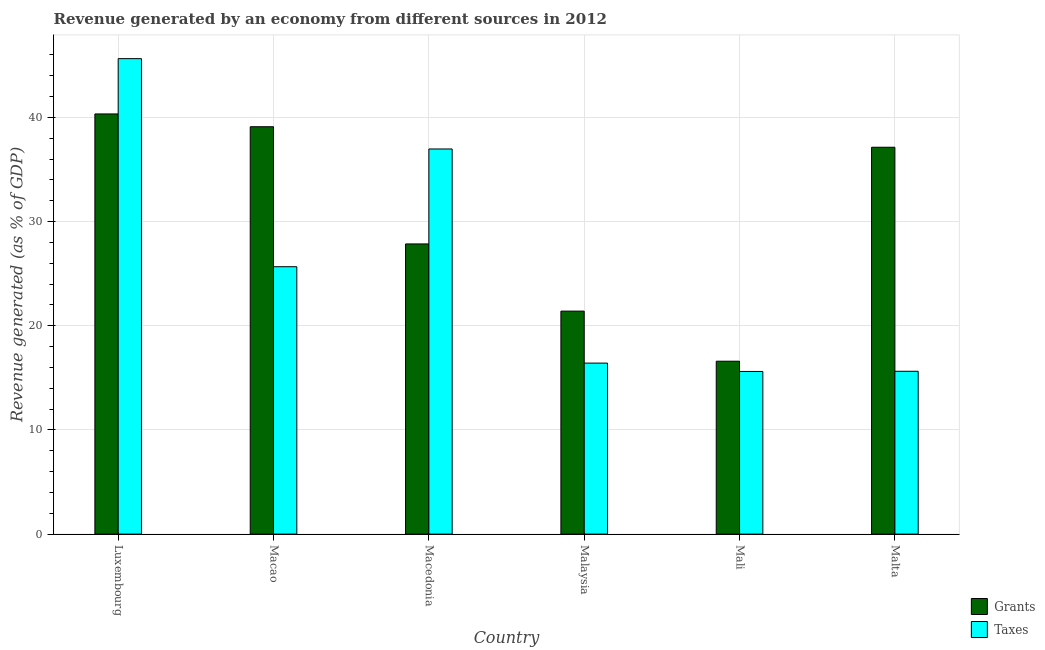How many different coloured bars are there?
Keep it short and to the point. 2. How many groups of bars are there?
Make the answer very short. 6. How many bars are there on the 2nd tick from the left?
Your response must be concise. 2. How many bars are there on the 5th tick from the right?
Your answer should be compact. 2. What is the label of the 3rd group of bars from the left?
Give a very brief answer. Macedonia. What is the revenue generated by grants in Macedonia?
Keep it short and to the point. 27.86. Across all countries, what is the maximum revenue generated by grants?
Your response must be concise. 40.34. Across all countries, what is the minimum revenue generated by grants?
Your answer should be very brief. 16.6. In which country was the revenue generated by taxes maximum?
Give a very brief answer. Luxembourg. In which country was the revenue generated by taxes minimum?
Ensure brevity in your answer.  Mali. What is the total revenue generated by grants in the graph?
Offer a very short reply. 182.44. What is the difference between the revenue generated by grants in Macao and that in Malaysia?
Your answer should be compact. 17.7. What is the difference between the revenue generated by taxes in Macao and the revenue generated by grants in Malta?
Provide a succinct answer. -11.47. What is the average revenue generated by taxes per country?
Your answer should be very brief. 25.99. What is the difference between the revenue generated by taxes and revenue generated by grants in Malaysia?
Give a very brief answer. -4.99. What is the ratio of the revenue generated by taxes in Malaysia to that in Malta?
Your answer should be very brief. 1.05. What is the difference between the highest and the second highest revenue generated by grants?
Provide a short and direct response. 1.23. What is the difference between the highest and the lowest revenue generated by taxes?
Make the answer very short. 30.03. In how many countries, is the revenue generated by taxes greater than the average revenue generated by taxes taken over all countries?
Give a very brief answer. 2. Is the sum of the revenue generated by taxes in Malaysia and Mali greater than the maximum revenue generated by grants across all countries?
Make the answer very short. No. What does the 2nd bar from the left in Luxembourg represents?
Your answer should be very brief. Taxes. What does the 1st bar from the right in Macedonia represents?
Offer a terse response. Taxes. Are all the bars in the graph horizontal?
Your answer should be compact. No. What is the difference between two consecutive major ticks on the Y-axis?
Offer a very short reply. 10. Are the values on the major ticks of Y-axis written in scientific E-notation?
Offer a terse response. No. Does the graph contain grids?
Provide a succinct answer. Yes. How many legend labels are there?
Give a very brief answer. 2. What is the title of the graph?
Your answer should be compact. Revenue generated by an economy from different sources in 2012. Does "Frequency of shipment arrival" appear as one of the legend labels in the graph?
Offer a terse response. No. What is the label or title of the Y-axis?
Provide a succinct answer. Revenue generated (as % of GDP). What is the Revenue generated (as % of GDP) in Grants in Luxembourg?
Offer a very short reply. 40.34. What is the Revenue generated (as % of GDP) in Taxes in Luxembourg?
Make the answer very short. 45.64. What is the Revenue generated (as % of GDP) in Grants in Macao?
Ensure brevity in your answer.  39.11. What is the Revenue generated (as % of GDP) in Taxes in Macao?
Keep it short and to the point. 25.67. What is the Revenue generated (as % of GDP) of Grants in Macedonia?
Provide a short and direct response. 27.86. What is the Revenue generated (as % of GDP) in Taxes in Macedonia?
Provide a short and direct response. 36.97. What is the Revenue generated (as % of GDP) in Grants in Malaysia?
Make the answer very short. 21.41. What is the Revenue generated (as % of GDP) in Taxes in Malaysia?
Keep it short and to the point. 16.42. What is the Revenue generated (as % of GDP) of Grants in Mali?
Your answer should be compact. 16.6. What is the Revenue generated (as % of GDP) of Taxes in Mali?
Provide a short and direct response. 15.61. What is the Revenue generated (as % of GDP) of Grants in Malta?
Ensure brevity in your answer.  37.14. What is the Revenue generated (as % of GDP) in Taxes in Malta?
Your response must be concise. 15.63. Across all countries, what is the maximum Revenue generated (as % of GDP) in Grants?
Give a very brief answer. 40.34. Across all countries, what is the maximum Revenue generated (as % of GDP) in Taxes?
Your answer should be compact. 45.64. Across all countries, what is the minimum Revenue generated (as % of GDP) in Grants?
Give a very brief answer. 16.6. Across all countries, what is the minimum Revenue generated (as % of GDP) of Taxes?
Offer a very short reply. 15.61. What is the total Revenue generated (as % of GDP) in Grants in the graph?
Provide a succinct answer. 182.44. What is the total Revenue generated (as % of GDP) in Taxes in the graph?
Offer a very short reply. 155.95. What is the difference between the Revenue generated (as % of GDP) in Grants in Luxembourg and that in Macao?
Keep it short and to the point. 1.23. What is the difference between the Revenue generated (as % of GDP) in Taxes in Luxembourg and that in Macao?
Your answer should be very brief. 19.97. What is the difference between the Revenue generated (as % of GDP) of Grants in Luxembourg and that in Macedonia?
Give a very brief answer. 12.48. What is the difference between the Revenue generated (as % of GDP) of Taxes in Luxembourg and that in Macedonia?
Make the answer very short. 8.67. What is the difference between the Revenue generated (as % of GDP) of Grants in Luxembourg and that in Malaysia?
Your answer should be very brief. 18.93. What is the difference between the Revenue generated (as % of GDP) of Taxes in Luxembourg and that in Malaysia?
Provide a succinct answer. 29.23. What is the difference between the Revenue generated (as % of GDP) of Grants in Luxembourg and that in Mali?
Your answer should be compact. 23.74. What is the difference between the Revenue generated (as % of GDP) in Taxes in Luxembourg and that in Mali?
Provide a succinct answer. 30.03. What is the difference between the Revenue generated (as % of GDP) of Grants in Luxembourg and that in Malta?
Your response must be concise. 3.2. What is the difference between the Revenue generated (as % of GDP) of Taxes in Luxembourg and that in Malta?
Your answer should be very brief. 30.01. What is the difference between the Revenue generated (as % of GDP) of Grants in Macao and that in Macedonia?
Make the answer very short. 11.25. What is the difference between the Revenue generated (as % of GDP) of Taxes in Macao and that in Macedonia?
Make the answer very short. -11.3. What is the difference between the Revenue generated (as % of GDP) in Grants in Macao and that in Malaysia?
Your response must be concise. 17.7. What is the difference between the Revenue generated (as % of GDP) in Taxes in Macao and that in Malaysia?
Your answer should be very brief. 9.25. What is the difference between the Revenue generated (as % of GDP) of Grants in Macao and that in Mali?
Provide a short and direct response. 22.51. What is the difference between the Revenue generated (as % of GDP) in Taxes in Macao and that in Mali?
Ensure brevity in your answer.  10.06. What is the difference between the Revenue generated (as % of GDP) of Grants in Macao and that in Malta?
Offer a very short reply. 1.97. What is the difference between the Revenue generated (as % of GDP) in Taxes in Macao and that in Malta?
Provide a short and direct response. 10.04. What is the difference between the Revenue generated (as % of GDP) of Grants in Macedonia and that in Malaysia?
Your answer should be compact. 6.45. What is the difference between the Revenue generated (as % of GDP) in Taxes in Macedonia and that in Malaysia?
Give a very brief answer. 20.56. What is the difference between the Revenue generated (as % of GDP) of Grants in Macedonia and that in Mali?
Make the answer very short. 11.26. What is the difference between the Revenue generated (as % of GDP) of Taxes in Macedonia and that in Mali?
Offer a very short reply. 21.36. What is the difference between the Revenue generated (as % of GDP) of Grants in Macedonia and that in Malta?
Offer a terse response. -9.28. What is the difference between the Revenue generated (as % of GDP) in Taxes in Macedonia and that in Malta?
Your response must be concise. 21.34. What is the difference between the Revenue generated (as % of GDP) of Grants in Malaysia and that in Mali?
Give a very brief answer. 4.81. What is the difference between the Revenue generated (as % of GDP) in Taxes in Malaysia and that in Mali?
Ensure brevity in your answer.  0.8. What is the difference between the Revenue generated (as % of GDP) of Grants in Malaysia and that in Malta?
Provide a succinct answer. -15.73. What is the difference between the Revenue generated (as % of GDP) of Taxes in Malaysia and that in Malta?
Keep it short and to the point. 0.78. What is the difference between the Revenue generated (as % of GDP) in Grants in Mali and that in Malta?
Make the answer very short. -20.54. What is the difference between the Revenue generated (as % of GDP) of Taxes in Mali and that in Malta?
Your answer should be very brief. -0.02. What is the difference between the Revenue generated (as % of GDP) in Grants in Luxembourg and the Revenue generated (as % of GDP) in Taxes in Macao?
Make the answer very short. 14.67. What is the difference between the Revenue generated (as % of GDP) in Grants in Luxembourg and the Revenue generated (as % of GDP) in Taxes in Macedonia?
Keep it short and to the point. 3.36. What is the difference between the Revenue generated (as % of GDP) in Grants in Luxembourg and the Revenue generated (as % of GDP) in Taxes in Malaysia?
Ensure brevity in your answer.  23.92. What is the difference between the Revenue generated (as % of GDP) in Grants in Luxembourg and the Revenue generated (as % of GDP) in Taxes in Mali?
Your answer should be compact. 24.72. What is the difference between the Revenue generated (as % of GDP) in Grants in Luxembourg and the Revenue generated (as % of GDP) in Taxes in Malta?
Give a very brief answer. 24.7. What is the difference between the Revenue generated (as % of GDP) in Grants in Macao and the Revenue generated (as % of GDP) in Taxes in Macedonia?
Offer a terse response. 2.14. What is the difference between the Revenue generated (as % of GDP) in Grants in Macao and the Revenue generated (as % of GDP) in Taxes in Malaysia?
Your answer should be very brief. 22.69. What is the difference between the Revenue generated (as % of GDP) in Grants in Macao and the Revenue generated (as % of GDP) in Taxes in Mali?
Your response must be concise. 23.49. What is the difference between the Revenue generated (as % of GDP) in Grants in Macao and the Revenue generated (as % of GDP) in Taxes in Malta?
Offer a terse response. 23.48. What is the difference between the Revenue generated (as % of GDP) in Grants in Macedonia and the Revenue generated (as % of GDP) in Taxes in Malaysia?
Your answer should be very brief. 11.44. What is the difference between the Revenue generated (as % of GDP) in Grants in Macedonia and the Revenue generated (as % of GDP) in Taxes in Mali?
Provide a short and direct response. 12.24. What is the difference between the Revenue generated (as % of GDP) of Grants in Macedonia and the Revenue generated (as % of GDP) of Taxes in Malta?
Offer a terse response. 12.22. What is the difference between the Revenue generated (as % of GDP) of Grants in Malaysia and the Revenue generated (as % of GDP) of Taxes in Mali?
Provide a succinct answer. 5.79. What is the difference between the Revenue generated (as % of GDP) in Grants in Malaysia and the Revenue generated (as % of GDP) in Taxes in Malta?
Provide a short and direct response. 5.77. What is the average Revenue generated (as % of GDP) in Grants per country?
Provide a short and direct response. 30.41. What is the average Revenue generated (as % of GDP) of Taxes per country?
Provide a succinct answer. 25.99. What is the difference between the Revenue generated (as % of GDP) of Grants and Revenue generated (as % of GDP) of Taxes in Luxembourg?
Offer a terse response. -5.31. What is the difference between the Revenue generated (as % of GDP) of Grants and Revenue generated (as % of GDP) of Taxes in Macao?
Offer a terse response. 13.44. What is the difference between the Revenue generated (as % of GDP) of Grants and Revenue generated (as % of GDP) of Taxes in Macedonia?
Your answer should be compact. -9.12. What is the difference between the Revenue generated (as % of GDP) in Grants and Revenue generated (as % of GDP) in Taxes in Malaysia?
Make the answer very short. 4.99. What is the difference between the Revenue generated (as % of GDP) in Grants and Revenue generated (as % of GDP) in Taxes in Mali?
Give a very brief answer. 0.98. What is the difference between the Revenue generated (as % of GDP) in Grants and Revenue generated (as % of GDP) in Taxes in Malta?
Offer a very short reply. 21.51. What is the ratio of the Revenue generated (as % of GDP) in Grants in Luxembourg to that in Macao?
Provide a short and direct response. 1.03. What is the ratio of the Revenue generated (as % of GDP) of Taxes in Luxembourg to that in Macao?
Your response must be concise. 1.78. What is the ratio of the Revenue generated (as % of GDP) of Grants in Luxembourg to that in Macedonia?
Your response must be concise. 1.45. What is the ratio of the Revenue generated (as % of GDP) in Taxes in Luxembourg to that in Macedonia?
Your answer should be very brief. 1.23. What is the ratio of the Revenue generated (as % of GDP) in Grants in Luxembourg to that in Malaysia?
Your answer should be compact. 1.88. What is the ratio of the Revenue generated (as % of GDP) of Taxes in Luxembourg to that in Malaysia?
Provide a short and direct response. 2.78. What is the ratio of the Revenue generated (as % of GDP) of Grants in Luxembourg to that in Mali?
Offer a terse response. 2.43. What is the ratio of the Revenue generated (as % of GDP) in Taxes in Luxembourg to that in Mali?
Your answer should be very brief. 2.92. What is the ratio of the Revenue generated (as % of GDP) in Grants in Luxembourg to that in Malta?
Provide a succinct answer. 1.09. What is the ratio of the Revenue generated (as % of GDP) in Taxes in Luxembourg to that in Malta?
Give a very brief answer. 2.92. What is the ratio of the Revenue generated (as % of GDP) of Grants in Macao to that in Macedonia?
Keep it short and to the point. 1.4. What is the ratio of the Revenue generated (as % of GDP) in Taxes in Macao to that in Macedonia?
Your answer should be very brief. 0.69. What is the ratio of the Revenue generated (as % of GDP) of Grants in Macao to that in Malaysia?
Your answer should be compact. 1.83. What is the ratio of the Revenue generated (as % of GDP) of Taxes in Macao to that in Malaysia?
Keep it short and to the point. 1.56. What is the ratio of the Revenue generated (as % of GDP) of Grants in Macao to that in Mali?
Keep it short and to the point. 2.36. What is the ratio of the Revenue generated (as % of GDP) in Taxes in Macao to that in Mali?
Offer a terse response. 1.64. What is the ratio of the Revenue generated (as % of GDP) in Grants in Macao to that in Malta?
Offer a terse response. 1.05. What is the ratio of the Revenue generated (as % of GDP) of Taxes in Macao to that in Malta?
Offer a very short reply. 1.64. What is the ratio of the Revenue generated (as % of GDP) in Grants in Macedonia to that in Malaysia?
Give a very brief answer. 1.3. What is the ratio of the Revenue generated (as % of GDP) in Taxes in Macedonia to that in Malaysia?
Offer a terse response. 2.25. What is the ratio of the Revenue generated (as % of GDP) of Grants in Macedonia to that in Mali?
Your answer should be compact. 1.68. What is the ratio of the Revenue generated (as % of GDP) in Taxes in Macedonia to that in Mali?
Keep it short and to the point. 2.37. What is the ratio of the Revenue generated (as % of GDP) of Grants in Macedonia to that in Malta?
Your answer should be compact. 0.75. What is the ratio of the Revenue generated (as % of GDP) in Taxes in Macedonia to that in Malta?
Offer a very short reply. 2.37. What is the ratio of the Revenue generated (as % of GDP) in Grants in Malaysia to that in Mali?
Your answer should be compact. 1.29. What is the ratio of the Revenue generated (as % of GDP) of Taxes in Malaysia to that in Mali?
Provide a succinct answer. 1.05. What is the ratio of the Revenue generated (as % of GDP) of Grants in Malaysia to that in Malta?
Your answer should be very brief. 0.58. What is the ratio of the Revenue generated (as % of GDP) in Taxes in Malaysia to that in Malta?
Keep it short and to the point. 1.05. What is the ratio of the Revenue generated (as % of GDP) of Grants in Mali to that in Malta?
Keep it short and to the point. 0.45. What is the ratio of the Revenue generated (as % of GDP) of Taxes in Mali to that in Malta?
Offer a very short reply. 1. What is the difference between the highest and the second highest Revenue generated (as % of GDP) of Grants?
Your answer should be very brief. 1.23. What is the difference between the highest and the second highest Revenue generated (as % of GDP) in Taxes?
Provide a short and direct response. 8.67. What is the difference between the highest and the lowest Revenue generated (as % of GDP) in Grants?
Your answer should be very brief. 23.74. What is the difference between the highest and the lowest Revenue generated (as % of GDP) in Taxes?
Your response must be concise. 30.03. 